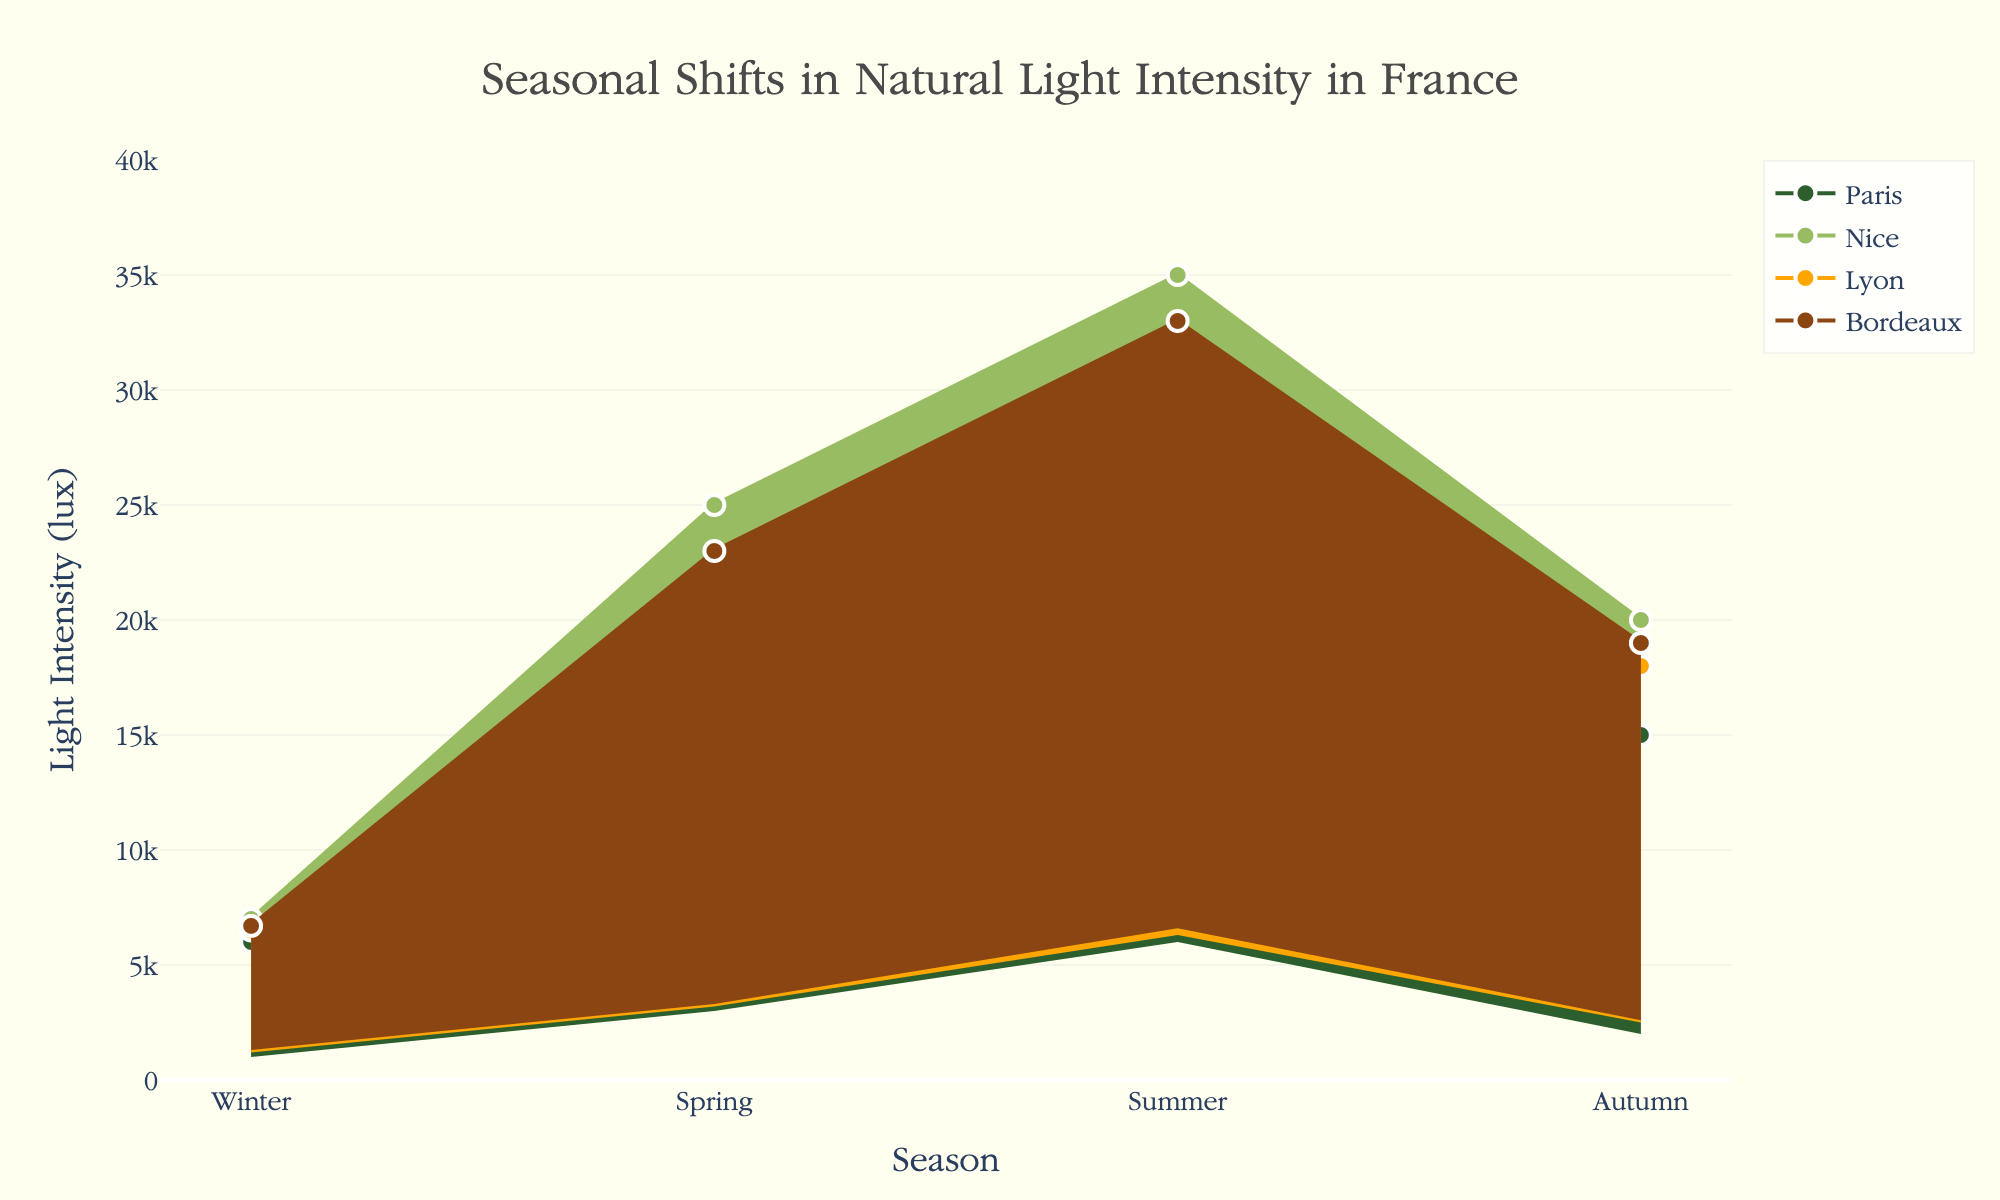How many different locations in France are represented in the plot? The plot includes data from four different locations in France, as evidenced by the unique labels on the figure.
Answer: 4 Which season exhibits the highest maximum light intensity in Nice? Observing the top values of the shaded area for Nice, the maximum light intensity is highest in Summer.
Answer: Summer What is the light intensity range in Paris during the Winter? In Paris, during Winter, the minimum light intensity is 1000 lux and the maximum is 6000 lux, resulting in a range from 1000 to 6000 lux.
Answer: 1000 to 6000 lux Which location has the greatest spread in light intensity during Winter? Comparing the difference between the maximum and minimum light intensities for Winter across all locations, Nice has the greatest spread from 7000 lux to 1500 lux, which is 5500 lux.
Answer: Nice In which season does Lyon experience the least variation in light intensity? By evaluating the gaps between the minimum and maximum light intensities across the seasons for Lyon, the least variation is during Winter, with a spread from 1200 to 6500 lux, a difference of 5300 lux.
Answer: Winter How does the maximum light intensity in Bordeaux during Autumn compare to that in Spring? The plot indicates the maximum light intensity in Bordeaux is 19000 lux in Autumn and 23000 lux in Spring, thus Spring has a higher maximum light intensity than Autumn.
Answer: Spring is higher What season ranges overlap between Paris and Bordeaux? Observing the overlapping light intensity ranges in the plot, during Autumn both locations have similar light intensity ranges between 2000-15000 lux for Paris and 2600-19000 lux for Bordeaux, indicating overlapping ranges.
Answer: Autumn Calculate the average maximum light intensity for each location during Summer and specify which city has the highest average. Calculate the maximum light intensities for Summer for all locations: 
Paris: 30000 lux
Nice: 35000 lux
Lyon: 32000 lux 
Bordeaux: 33000 lux 
Then calculate the average, (30000 + 35000 + 32000 + 33000) / 4 = 32500 lux. Nice has the highest maximum light intensity during Summer.
Answer: Nice Compare the light intensity ranges across all locations in Spring; which location has the highest minimum light intensity? By looking at the Spring minimum light intensities, Paris: 3000 lux, Nice: 3500 lux, Lyon: 3200 lux, and Bordeaux: 3300 lux, we can see that Nice has the highest minimum light intensity.
Answer: Nice 